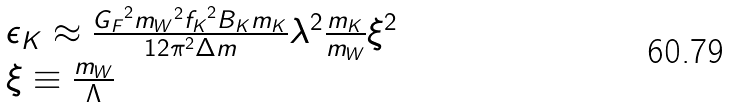<formula> <loc_0><loc_0><loc_500><loc_500>\begin{array} { l } { { \epsilon _ { K } \approx \frac { { G _ { F } } ^ { 2 } { m _ { W } } ^ { 2 } { f _ { K } } ^ { 2 } B _ { K } m _ { K } } { 1 2 \pi ^ { 2 } \Delta m } \lambda ^ { 2 } \frac { m _ { K } } { m _ { W } } \xi ^ { 2 } } } \\ { { \xi \equiv \frac { m _ { W } } { \Lambda } } } \end{array}</formula> 